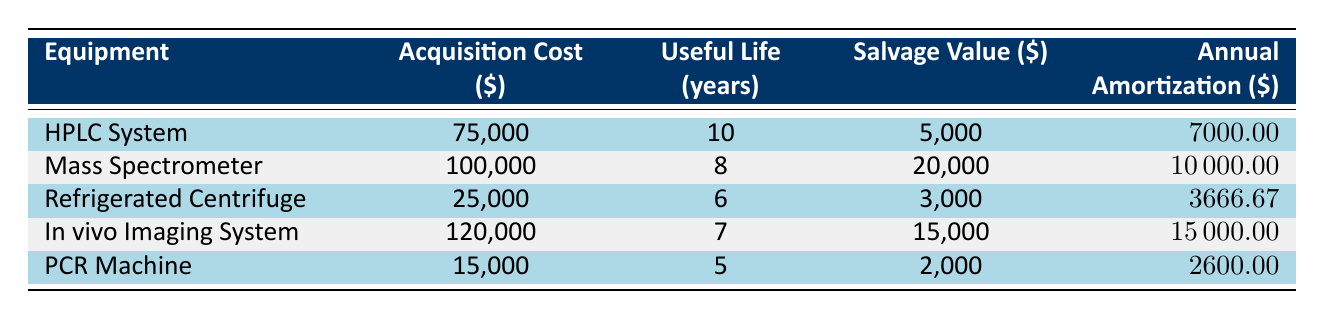What's the acquisition cost of the Mass Spectrometer? The table lists the acquisition cost of the Mass Spectrometer under the "Acquisition Cost" column, which is stated as 100,000.
Answer: 100,000 What is the annual amortization cost for the Refrigerated Centrifuge? The annual amortization for the Refrigerated Centrifuge is found in the "Annual Amortization" column, which shows 3,666.67.
Answer: 3,666.67 Which piece of equipment has the highest salvage value? By comparing the "Salvage Value" column, the In vivo Imaging System has the highest salvage value at 15,000.
Answer: In vivo Imaging System Is the useful life of the PCR Machine greater than 5 years? The useful life of the PCR Machine is exactly 5 years, which means it is not greater than 5 years, thus the statement is false.
Answer: No What is the total acquisition cost of all listed laboratory equipment? The total acquisition cost is calculated by summing the acquisition costs of all equipment: 75,000 + 100,000 + 25,000 + 120,000 + 15,000 = 335,000.
Answer: 335,000 Does the HPLC System have a higher annual amortization than the Mass Spectrometer? The HPLC System's annual amortization is 7,000, while the Mass Spectrometer’s is 10,000. Since 7,000 is less than 10,000, this statement is false.
Answer: No What is the average annual amortization of the laboratory equipment? To find the average, first add up all the annual amortization amounts: 7,000 + 10,000 + 3,666.67 + 15,000 + 2,600 = 38,266.67. Then, divide by the number of equipment (5): 38,266.67 / 5 = 7,653.33.
Answer: 7,653.33 Which equipment has the lowest acquisition cost? By reviewing the "Acquisition Cost" column, the Refrigerated Centrifuge has the lowest cost at 25,000.
Answer: Refrigerated Centrifuge What is the difference in annual amortization between the In vivo Imaging System and the PCR Machine? The annual amortization for the In vivo Imaging System is 15,000, and for the PCR Machine is 2,600. Subtracting these gives the difference: 15,000 - 2,600 = 12,400.
Answer: 12,400 